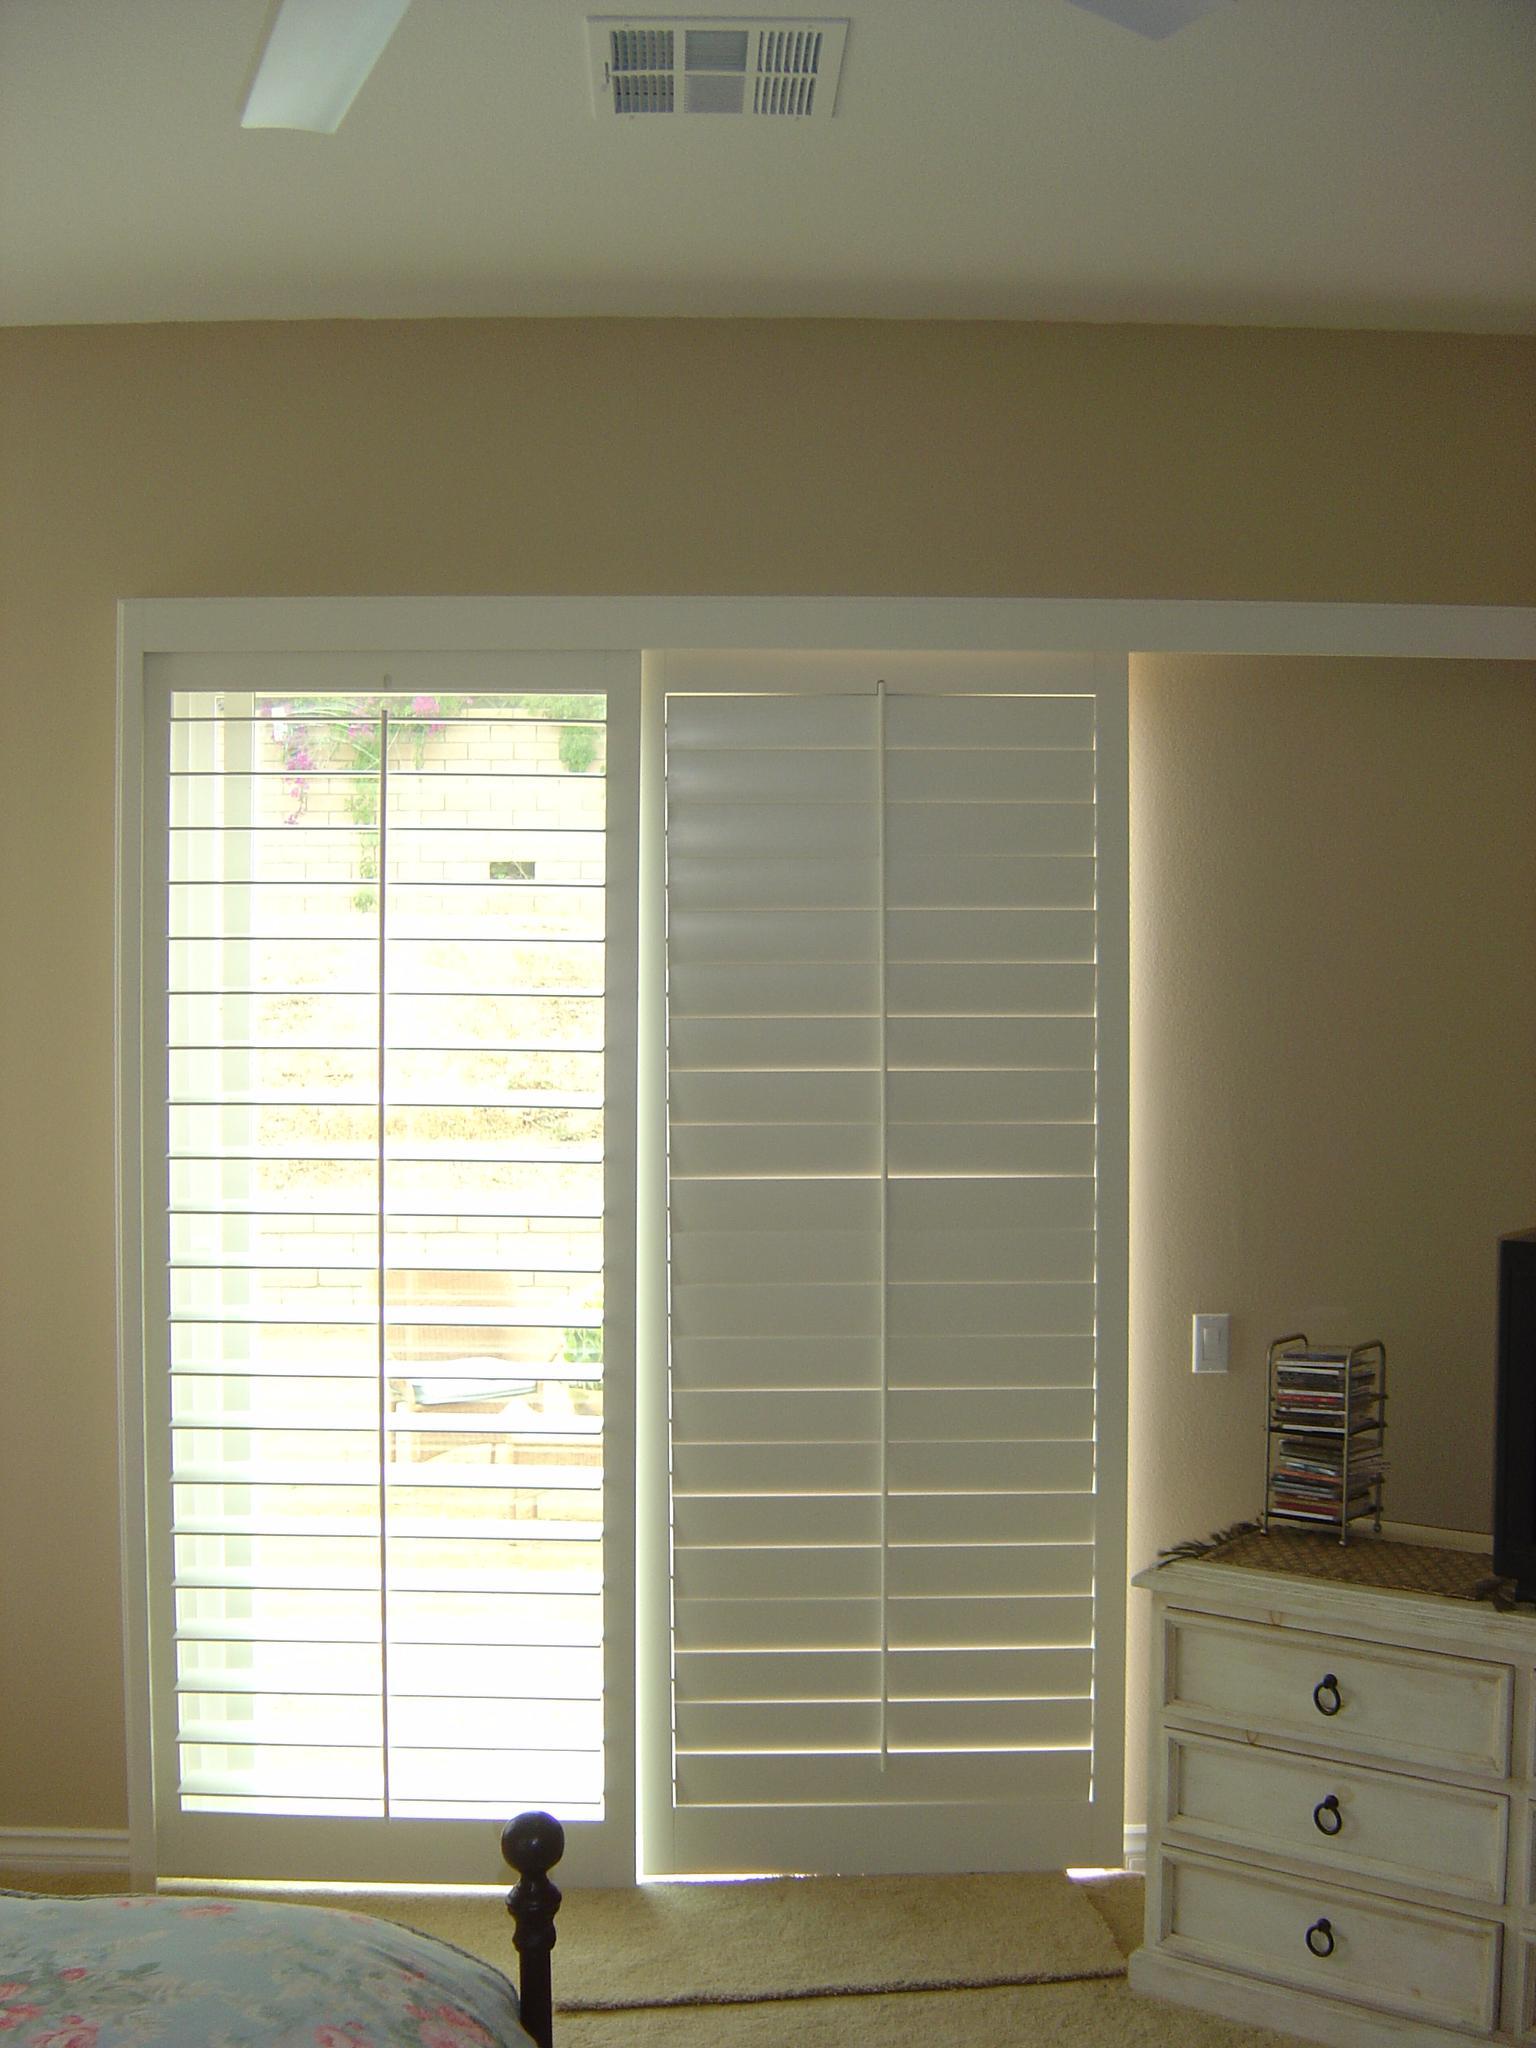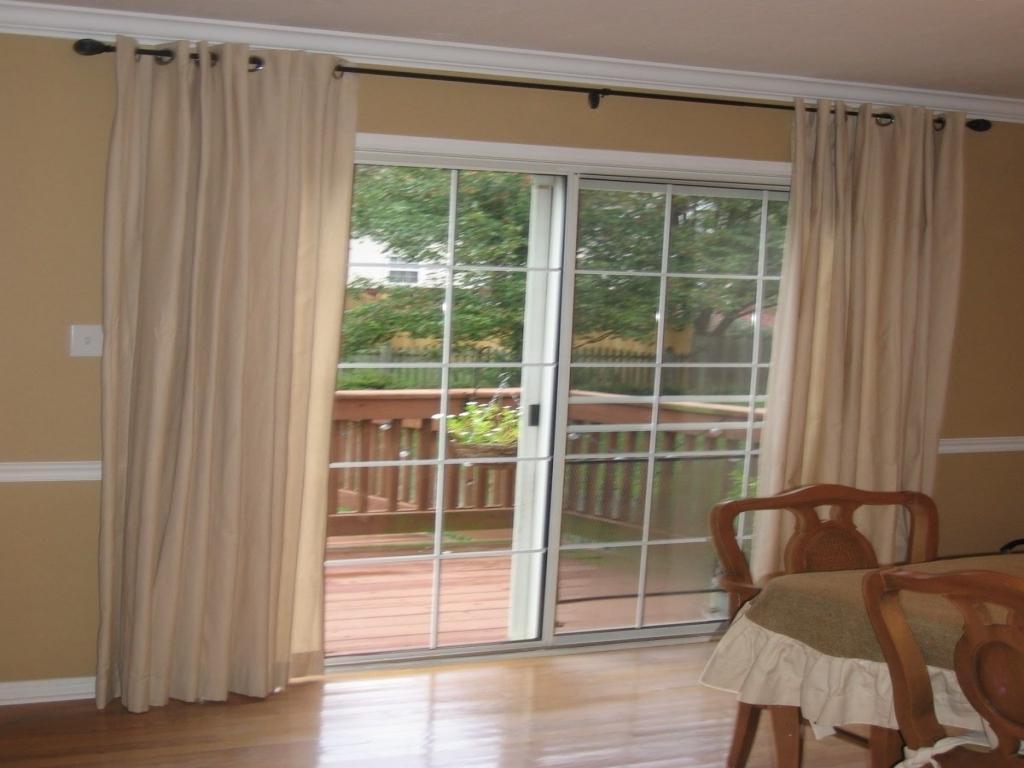The first image is the image on the left, the second image is the image on the right. For the images displayed, is the sentence "The patio doors in one of the images are framed by curtains on either side." factually correct? Answer yes or no. Yes. The first image is the image on the left, the second image is the image on the right. Considering the images on both sides, is "The windows in the left image have drapes." valid? Answer yes or no. No. 